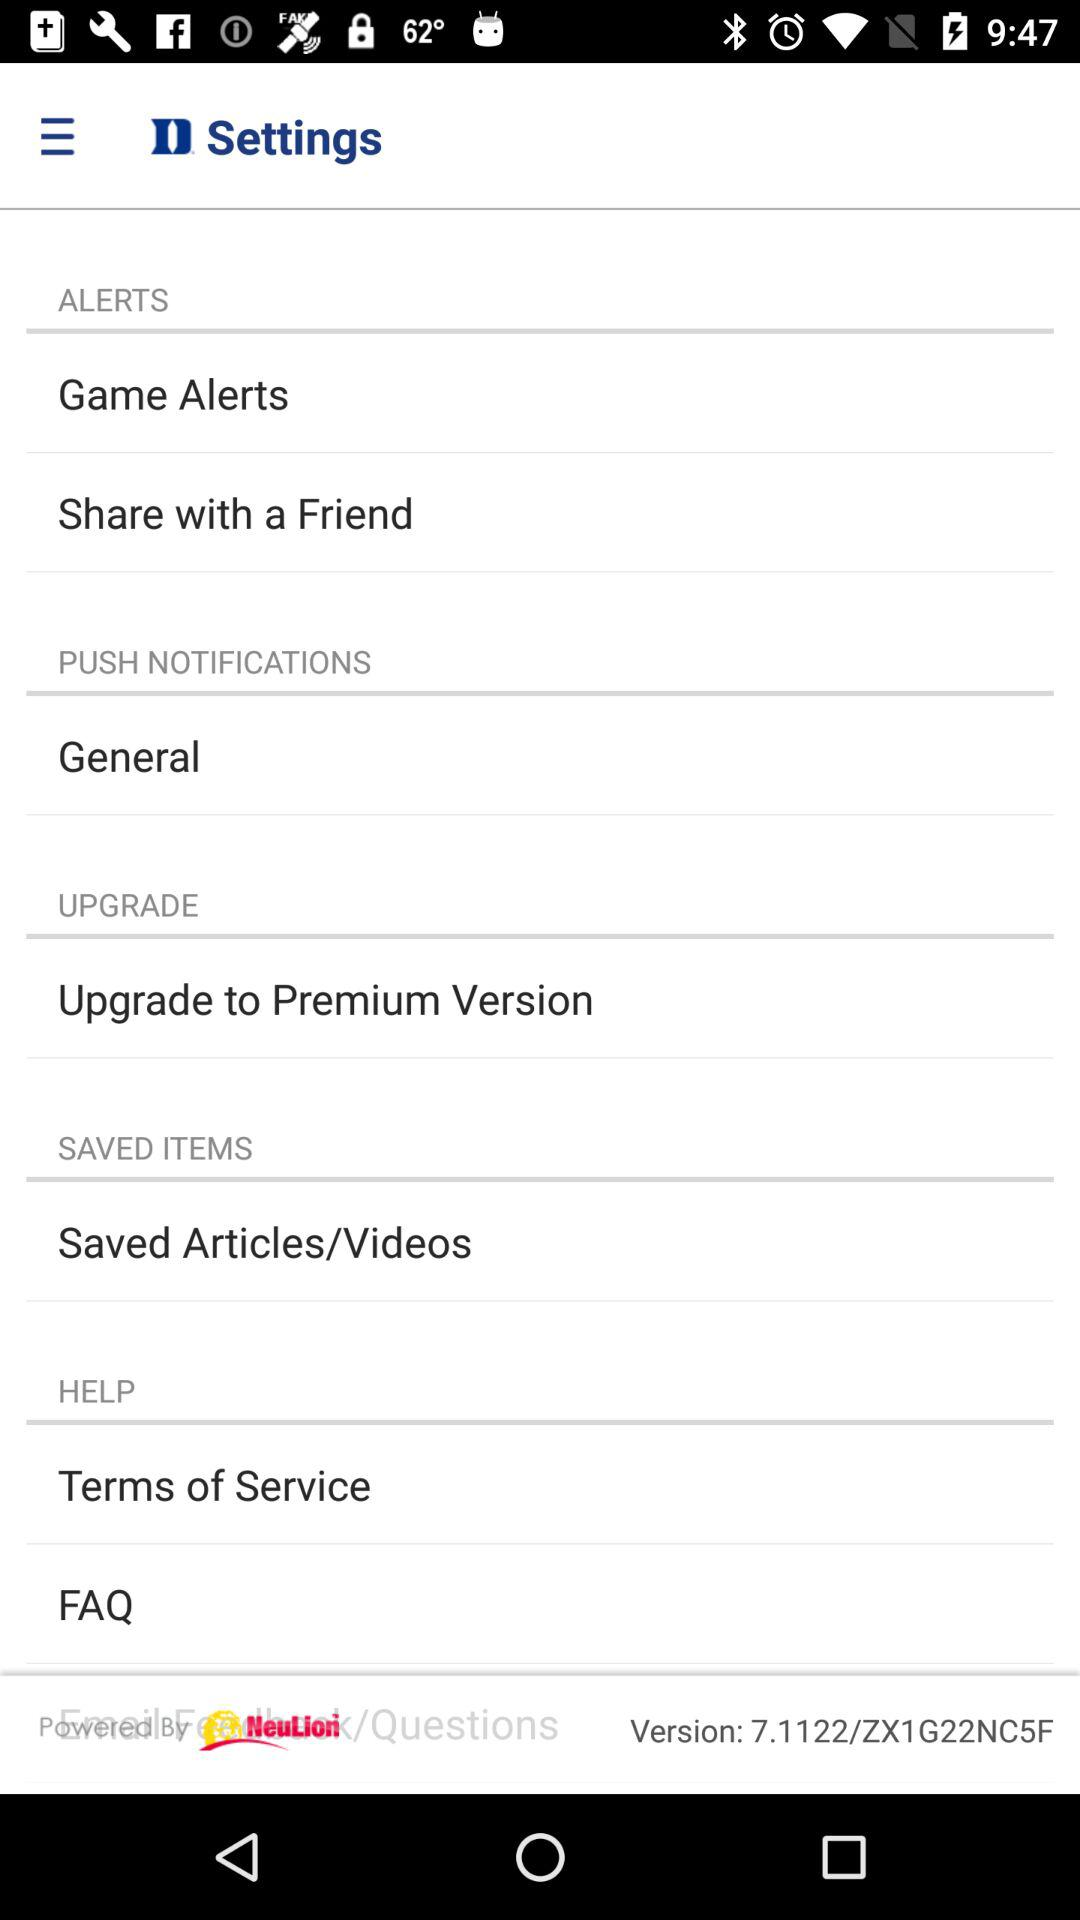What is the current version? The current version is 7.1122/ZX1G22NC5F. 